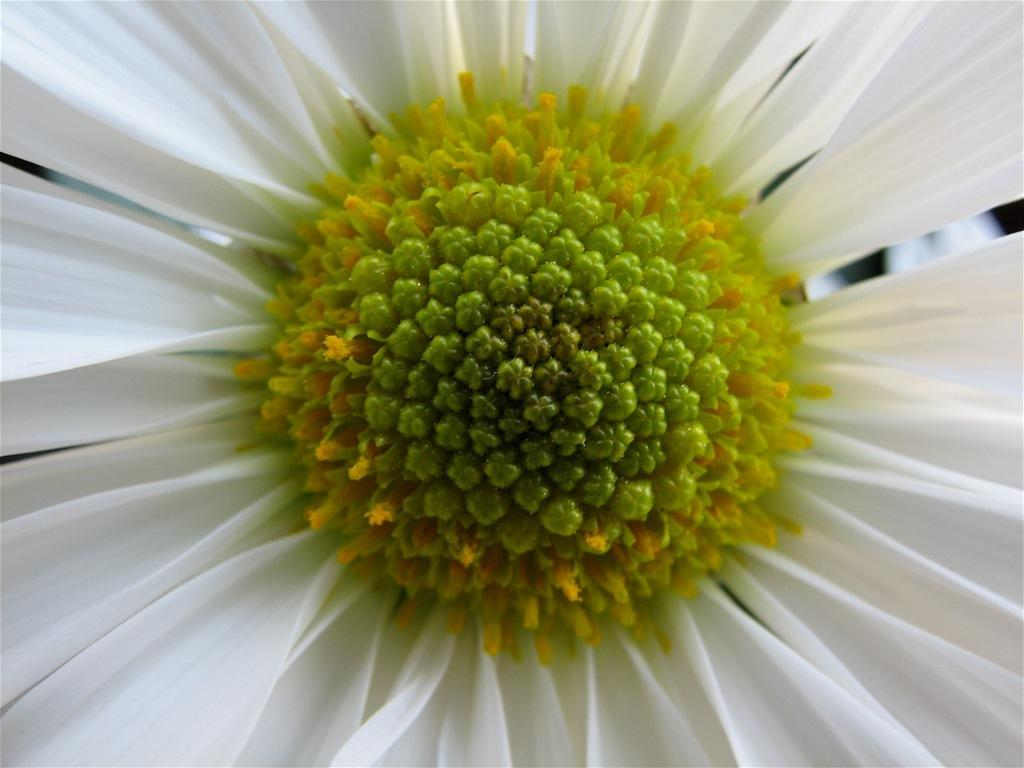What is the main subject of the image? There is a flower in the image. Where is the flower located in the image? The flower is in the center of the image. What color are the petals of the flower? The flower has white-colored petals. How many marbles are scattered around the flower in the image? There are no marbles present in the image; it only features a flower with white-colored petals. 